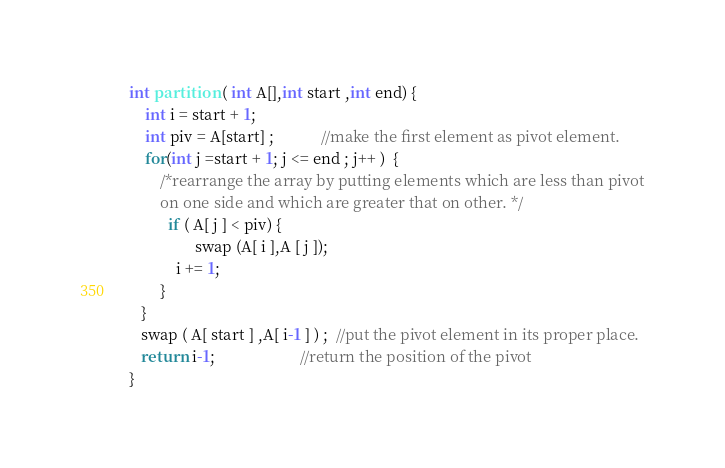Convert code to text. <code><loc_0><loc_0><loc_500><loc_500><_C++_>int partition ( int A[],int start ,int end) {
    int i = start + 1;
    int piv = A[start] ;            //make the first element as pivot element.
    for(int j =start + 1; j <= end ; j++ )  {
        /*rearrange the array by putting elements which are less than pivot
        on one side and which are greater that on other. */
          if ( A[ j ] < piv) {
                 swap (A[ i ],A [ j ]);
            i += 1;
        }
   }
   swap ( A[ start ] ,A[ i-1 ] ) ;  //put the pivot element in its proper place.
   return i-1;                      //return the position of the pivot
}</code> 